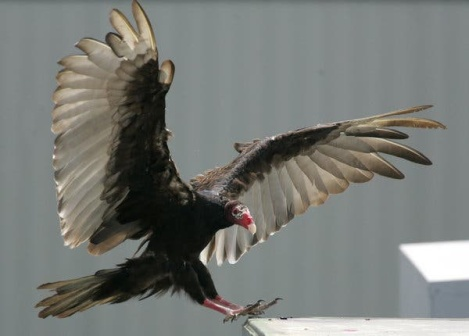What might the vulture be thinking? The vulture, gliding to the rooftop, might be assessing its surroundings. Perched high, it contemplates the thermals of the wind and the potential sights below. It might be thinking about its next meal, scanning for signs of movement or decay that indicate sustenance. Or perhaps, in a more abstract musing, it feels the innate pull of its species’ instincts, a blend of survival and the subtle dance with the skies that only a creature of such grandeur can understand. 